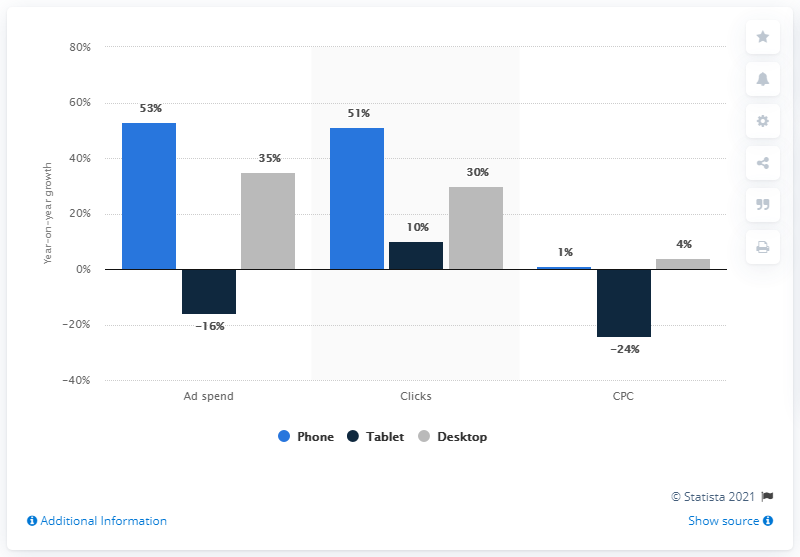Point out several critical features in this image. Google's paid search advertising spend on mobile phones, through their Product Listing Ads (PLA), increased by 53% in the first quarter of 2017. 